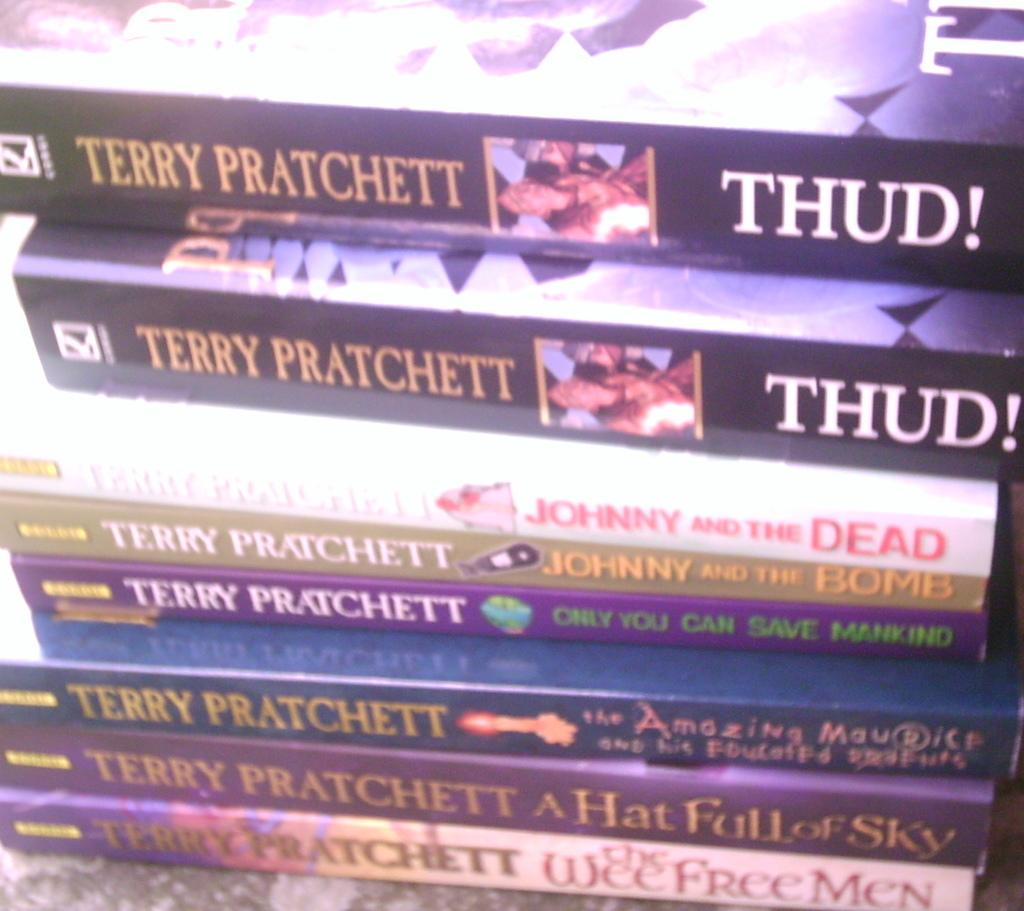<image>
Share a concise interpretation of the image provided. About 7 or more book series of Terry Pratchett stacked on top of each other. 